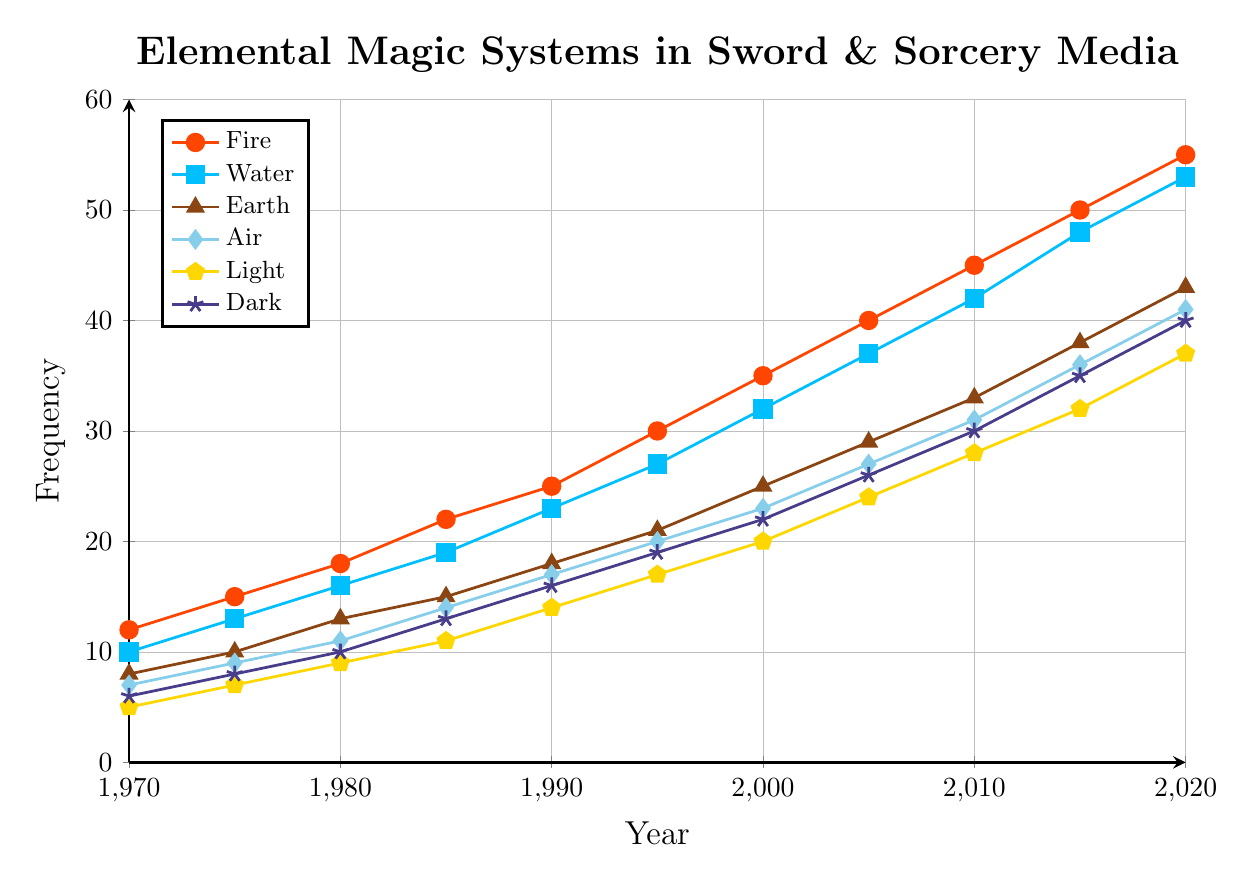What is the frequency of Fire magic systems in 1990? In the year 1990, the line corresponding to Fire magic systems reaches a value of 25 on the y-axis.
Answer: 25 What is the sum of the frequencies of Light and Dark magic systems in 2010? In 2010, Light magic systems had a frequency of 28, and Dark magic systems had a frequency of 30. The sum is 28 + 30 = 58.
Answer: 58 Which elemental magic system shows the steepest increase in frequency from 2000 to 2010? Calculating the increase from 2000 to 2010, Fire increased by 10, Water by 10, Earth by 8, Air by 8, Light by 8, and Dark by 8. All magic systems increased equally.
Answer: Fire, Water, Earth, Air, Light, Dark 